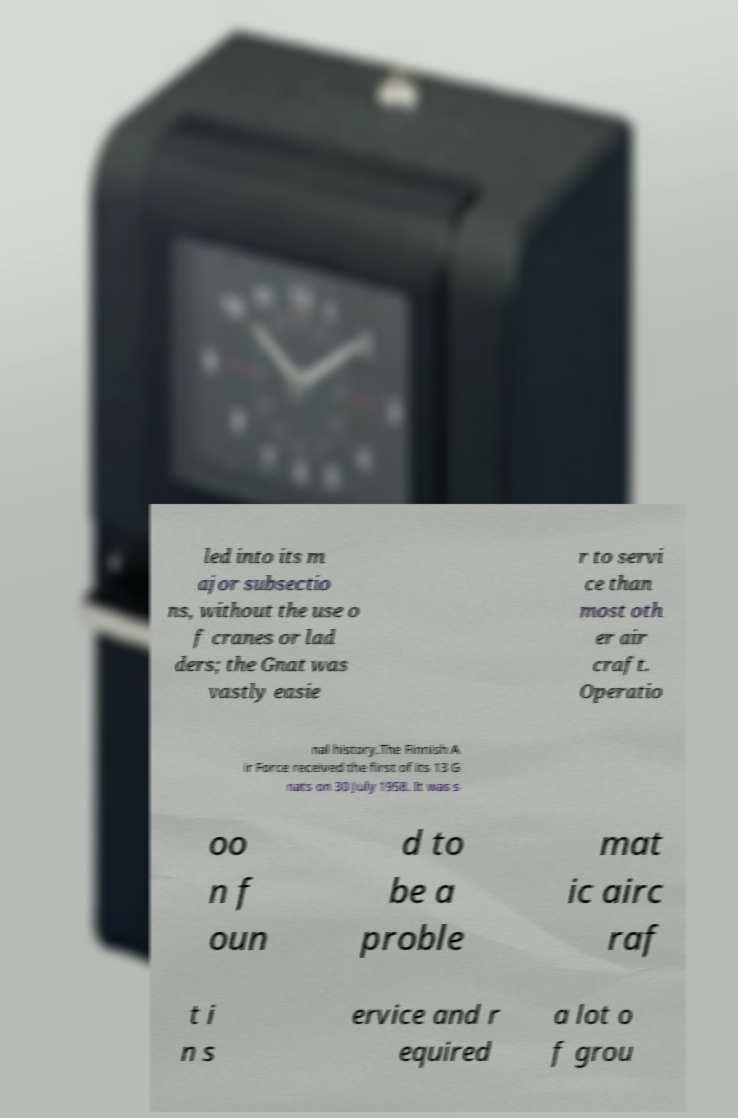Could you assist in decoding the text presented in this image and type it out clearly? led into its m ajor subsectio ns, without the use o f cranes or lad ders; the Gnat was vastly easie r to servi ce than most oth er air craft. Operatio nal history.The Finnish A ir Force received the first of its 13 G nats on 30 July 1958. It was s oo n f oun d to be a proble mat ic airc raf t i n s ervice and r equired a lot o f grou 